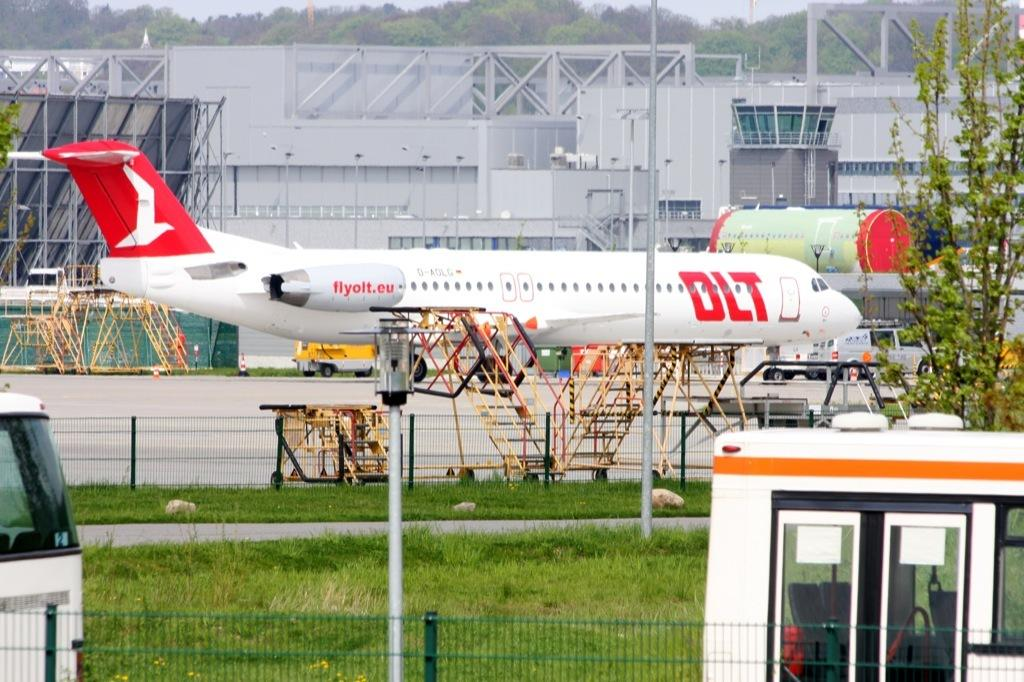<image>
Summarize the visual content of the image. A white and red airplane with the words flyolt.eu on it 